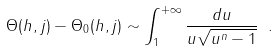Convert formula to latex. <formula><loc_0><loc_0><loc_500><loc_500>\Theta ( h , j ) - \Theta _ { 0 } ( h , j ) \sim \int _ { 1 } ^ { + \infty } \frac { d u } { u \sqrt { u ^ { n } - 1 } } \ .</formula> 